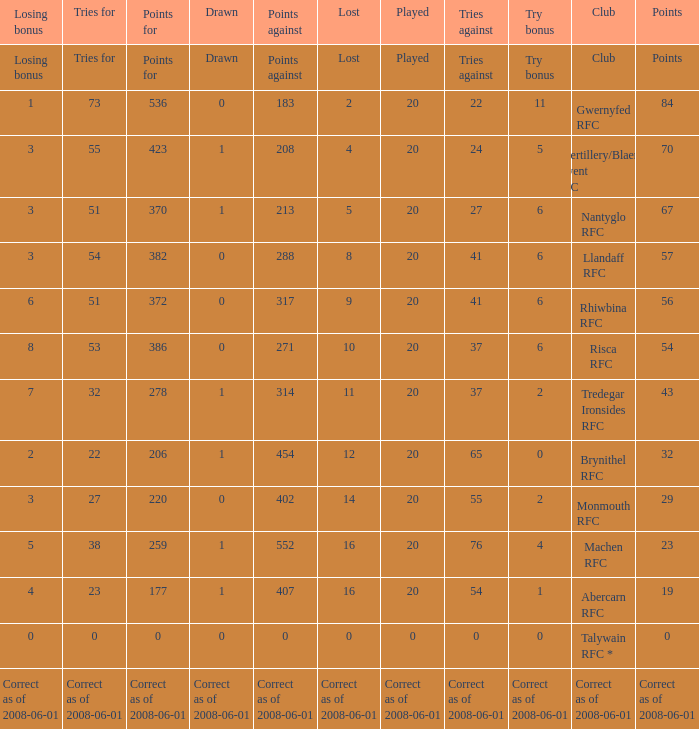What's the try bonus that had 423 points? 5.0. 